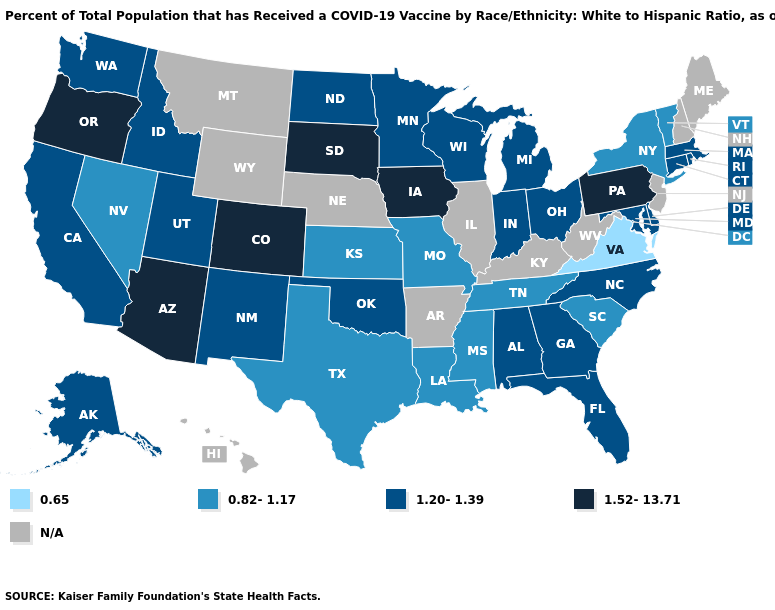What is the value of Louisiana?
Short answer required. 0.82-1.17. What is the lowest value in states that border Massachusetts?
Concise answer only. 0.82-1.17. Does Tennessee have the highest value in the USA?
Write a very short answer. No. Does the map have missing data?
Concise answer only. Yes. Does Virginia have the lowest value in the USA?
Keep it brief. Yes. What is the value of Massachusetts?
Quick response, please. 1.20-1.39. What is the value of Oklahoma?
Be succinct. 1.20-1.39. Name the states that have a value in the range 0.65?
Write a very short answer. Virginia. Name the states that have a value in the range N/A?
Concise answer only. Arkansas, Hawaii, Illinois, Kentucky, Maine, Montana, Nebraska, New Hampshire, New Jersey, West Virginia, Wyoming. What is the value of Michigan?
Quick response, please. 1.20-1.39. Name the states that have a value in the range 0.82-1.17?
Give a very brief answer. Kansas, Louisiana, Mississippi, Missouri, Nevada, New York, South Carolina, Tennessee, Texas, Vermont. What is the value of Virginia?
Quick response, please. 0.65. Does Missouri have the lowest value in the MidWest?
Give a very brief answer. Yes. What is the lowest value in states that border Oklahoma?
Keep it brief. 0.82-1.17. Does Idaho have the highest value in the West?
Give a very brief answer. No. 